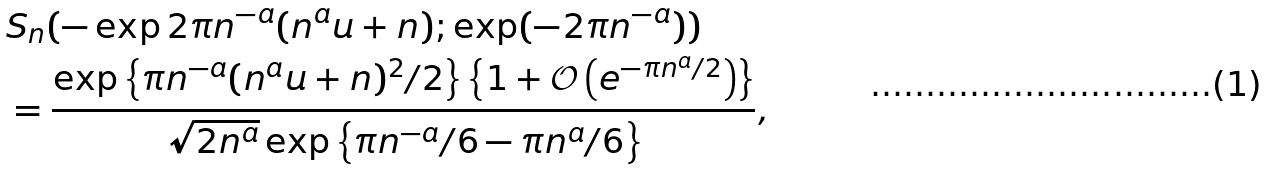<formula> <loc_0><loc_0><loc_500><loc_500>& S _ { n } ( - \exp 2 \pi n ^ { - a } ( n ^ { a } u + n ) ; \exp ( - 2 \pi n ^ { - a } ) ) \\ & = \frac { \exp \left \{ \pi n ^ { - a } ( n ^ { a } u + n ) ^ { 2 } / 2 \right \} \left \{ 1 + \mathcal { O } \left ( e ^ { - \pi n ^ { a } / 2 } \right ) \right \} } { \sqrt { 2 n ^ { a } } \exp \left \{ \pi n ^ { - a } / 6 - \pi n ^ { a } / 6 \right \} } ,</formula> 